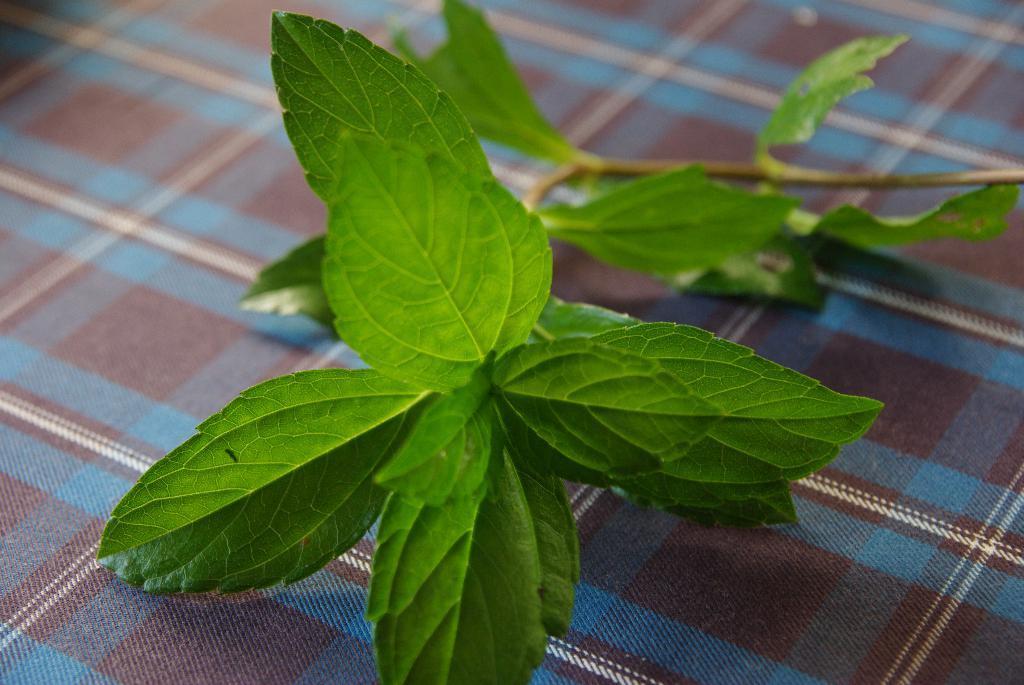Can you describe this image briefly? In the center of the image we can see leaves placed on the table. 